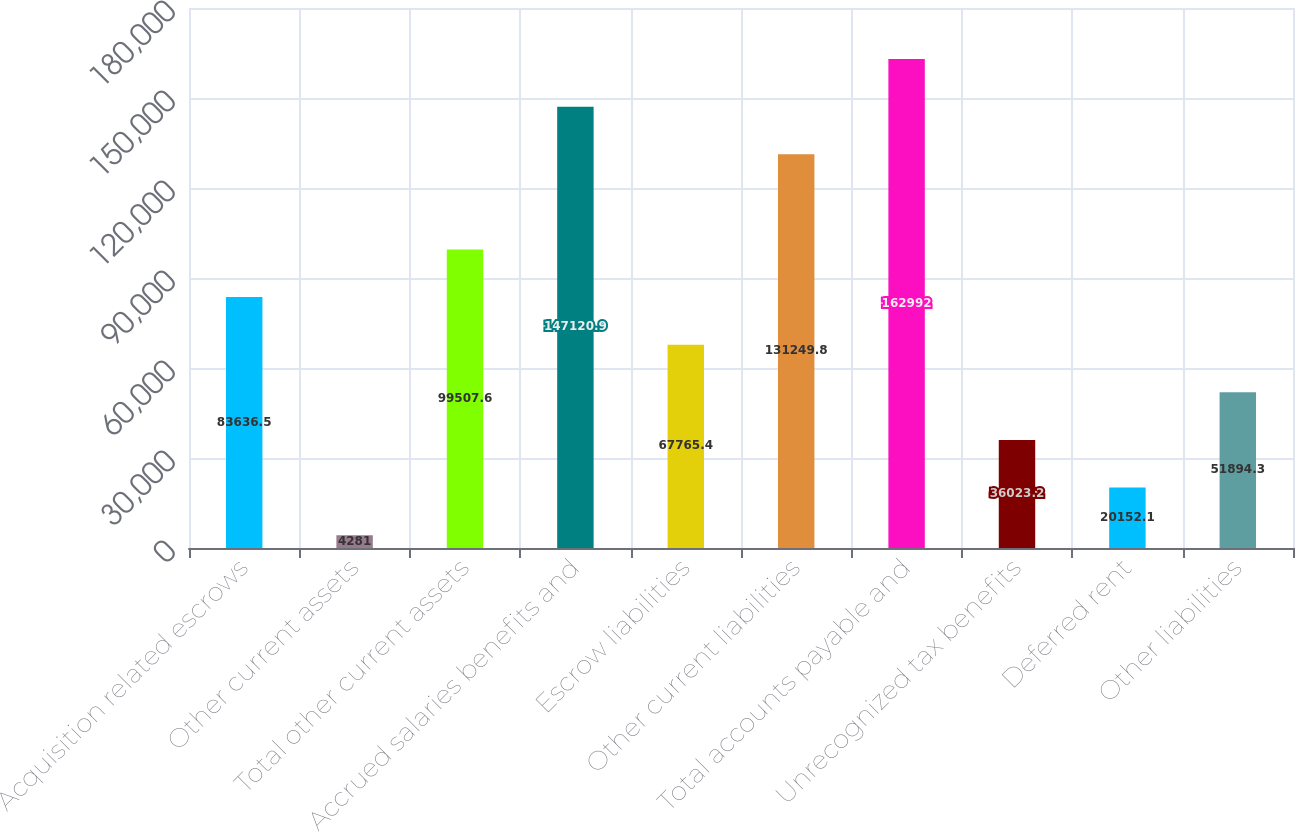Convert chart. <chart><loc_0><loc_0><loc_500><loc_500><bar_chart><fcel>Acquisition related escrows<fcel>Other current assets<fcel>Total other current assets<fcel>Accrued salaries benefits and<fcel>Escrow liabilities<fcel>Other current liabilities<fcel>Total accounts payable and<fcel>Unrecognized tax benefits<fcel>Deferred rent<fcel>Other liabilities<nl><fcel>83636.5<fcel>4281<fcel>99507.6<fcel>147121<fcel>67765.4<fcel>131250<fcel>162992<fcel>36023.2<fcel>20152.1<fcel>51894.3<nl></chart> 